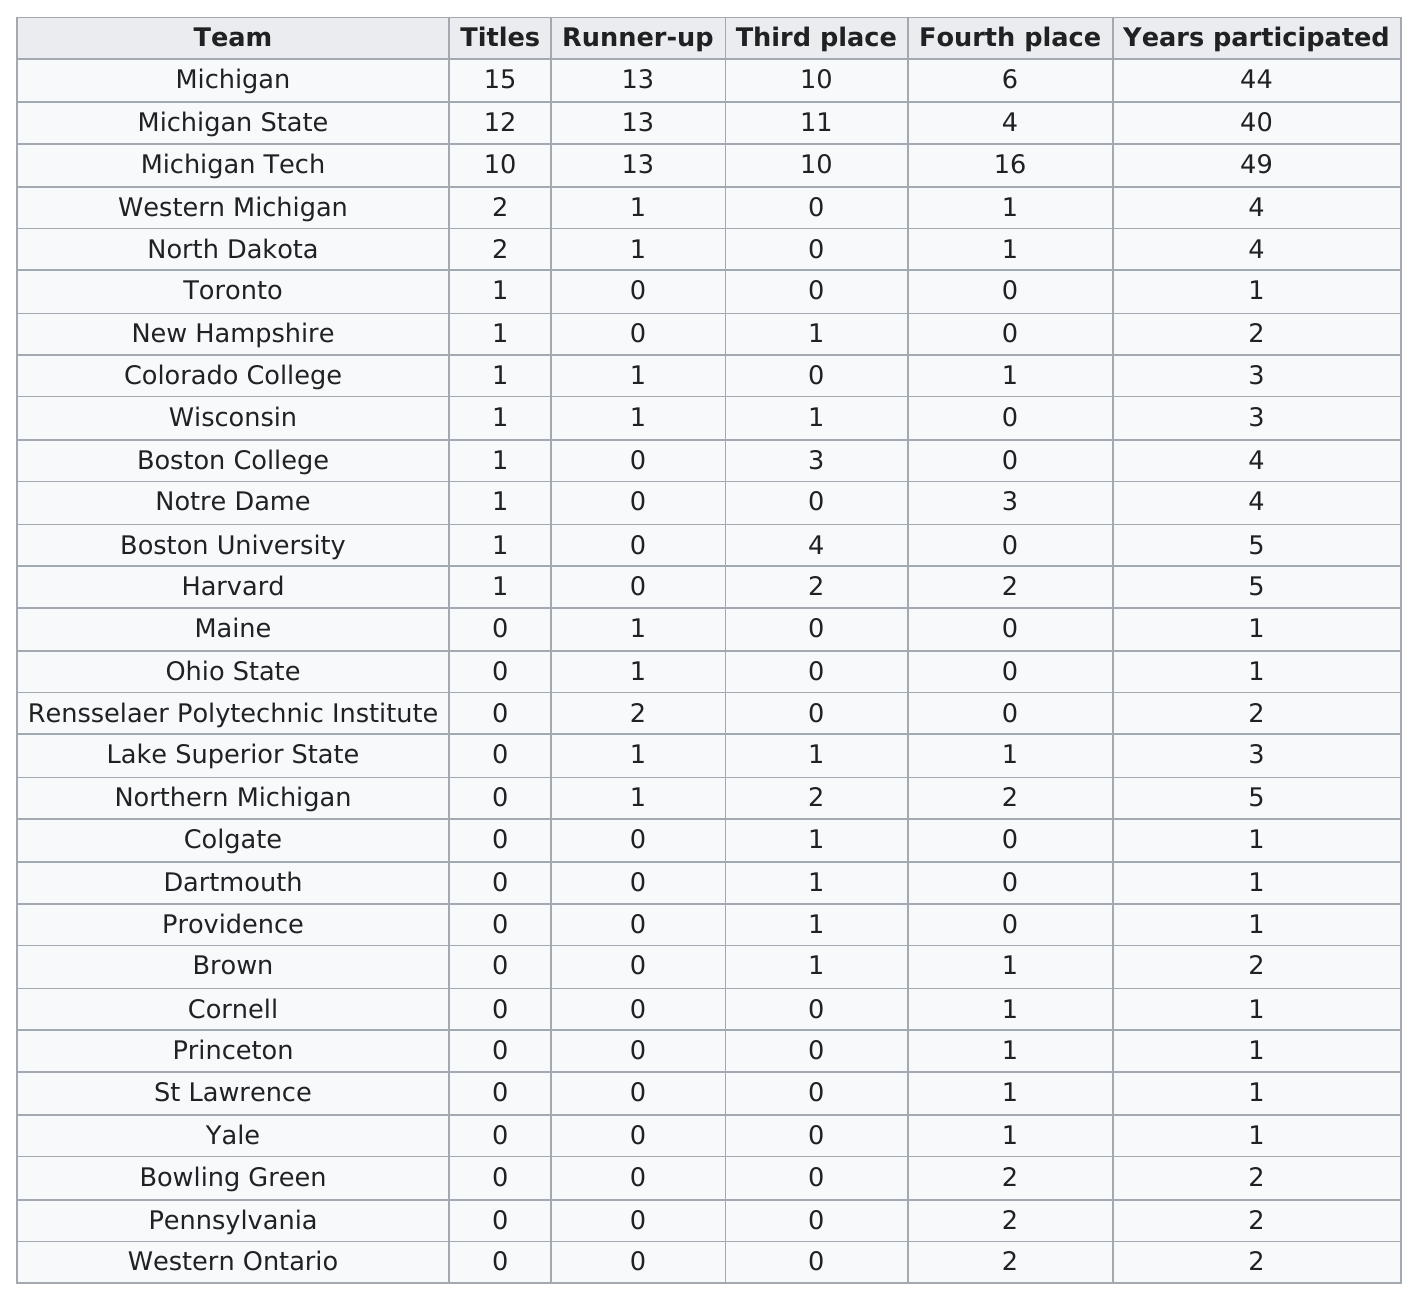Identify some key points in this picture. Michigan Tech has placed fourth the most times out of all the schools. Michigan Tech had the most fourth place finishes in a team competition. Michigan Tech has the longest history of participation in comparison to other teams or organizations in the state of Michigan. Michigan has the most titles at the Great Lakes Invitational. Michigan State had more titles than Colorado College. 